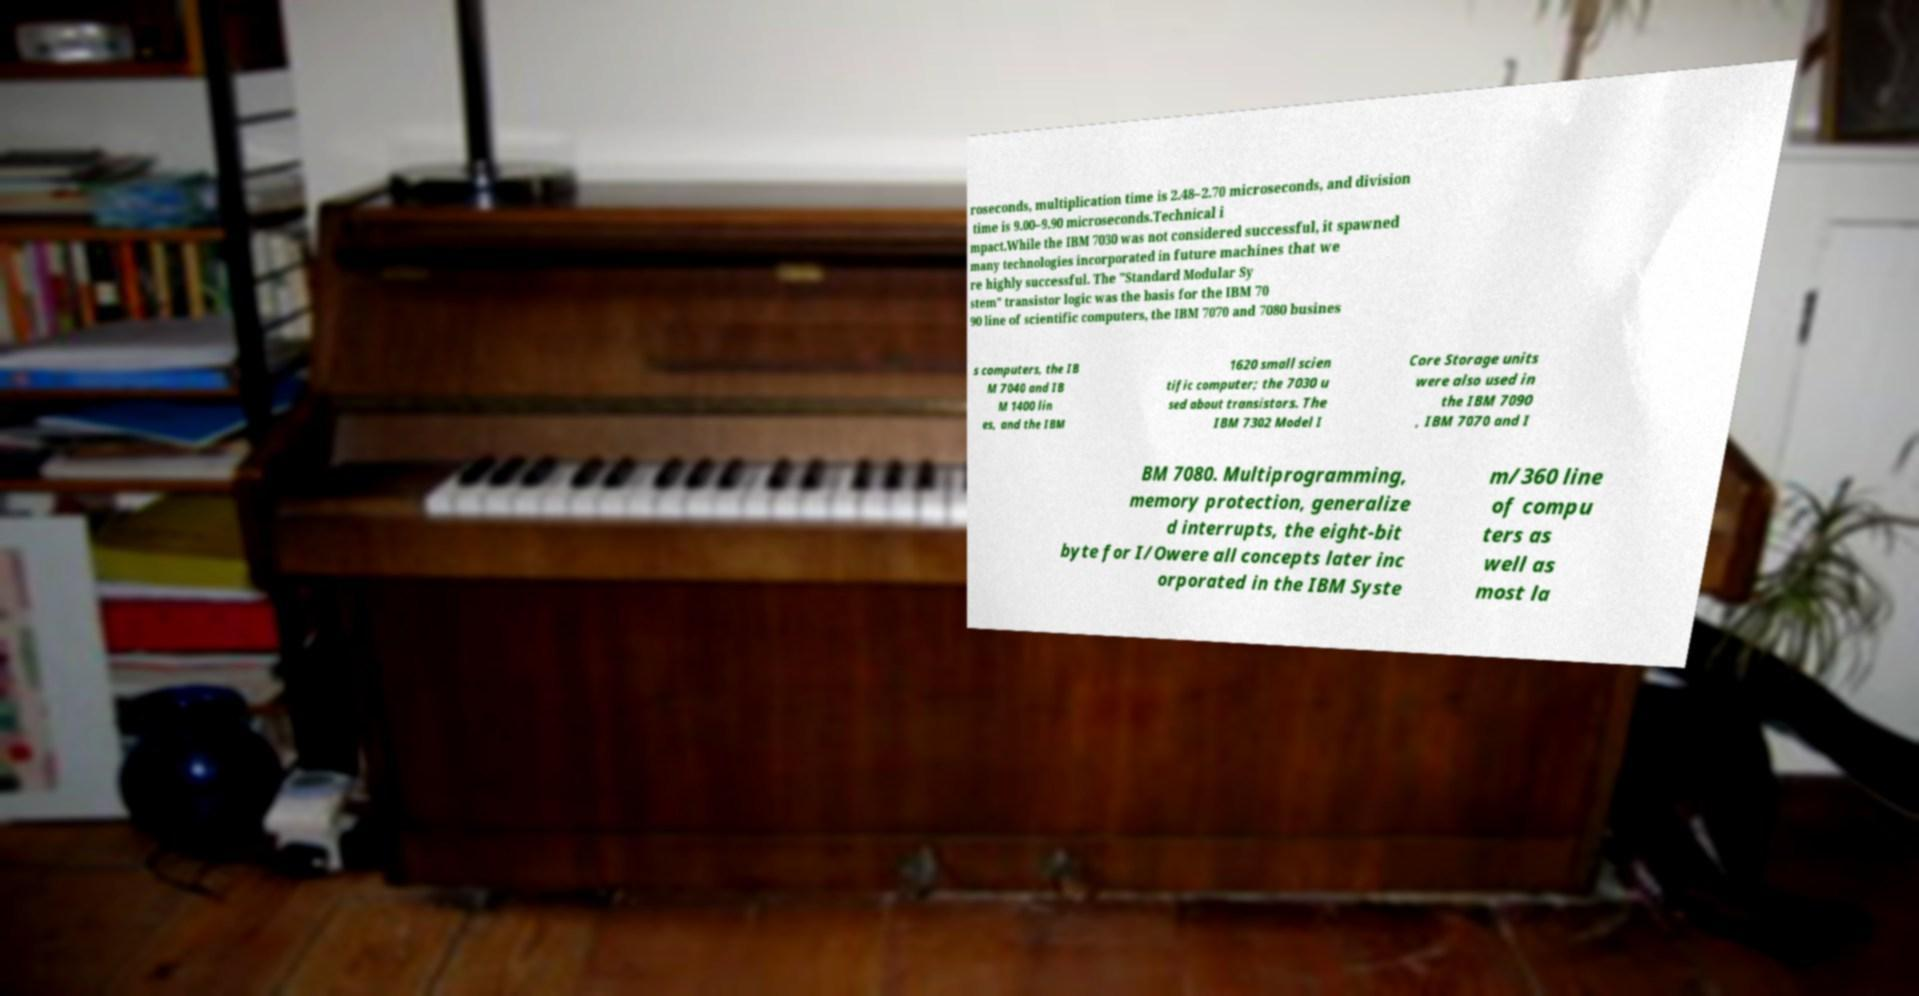Please identify and transcribe the text found in this image. roseconds, multiplication time is 2.48–2.70 microseconds, and division time is 9.00–9.90 microseconds.Technical i mpact.While the IBM 7030 was not considered successful, it spawned many technologies incorporated in future machines that we re highly successful. The "Standard Modular Sy stem" transistor logic was the basis for the IBM 70 90 line of scientific computers, the IBM 7070 and 7080 busines s computers, the IB M 7040 and IB M 1400 lin es, and the IBM 1620 small scien tific computer; the 7030 u sed about transistors. The IBM 7302 Model I Core Storage units were also used in the IBM 7090 , IBM 7070 and I BM 7080. Multiprogramming, memory protection, generalize d interrupts, the eight-bit byte for I/Owere all concepts later inc orporated in the IBM Syste m/360 line of compu ters as well as most la 